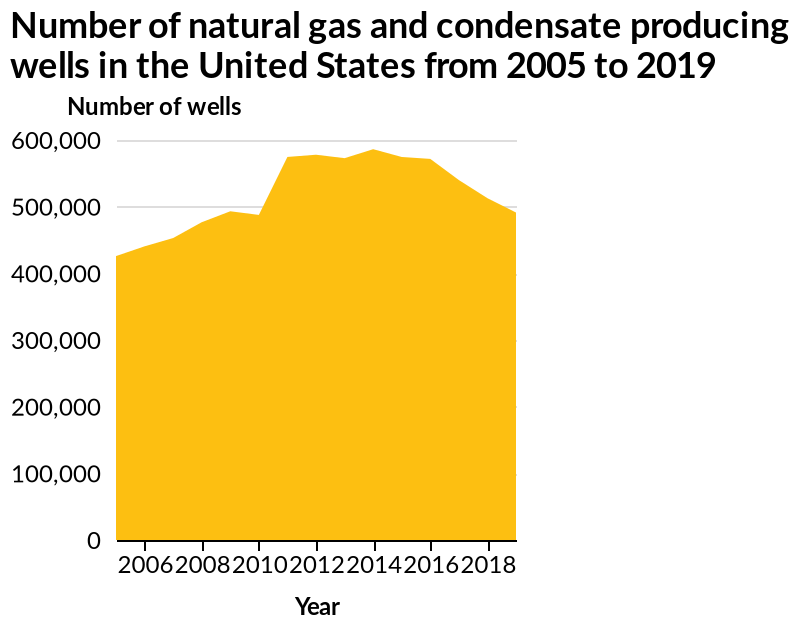<image>
please summary the statistics and relations of the chart Overall, the line indicates a growth in natural gas and condensate producing wells from 2005 to 2011, with an increase from roughly 440,000 to 580,000. This number remained roughly constant from 2011 to 2016 before beginning to drop to about 500,000 by 2018. What happened to the number of natural gas and condensate producing wells after 2016? The number started to drop and reached about 500,000 by 2018. 